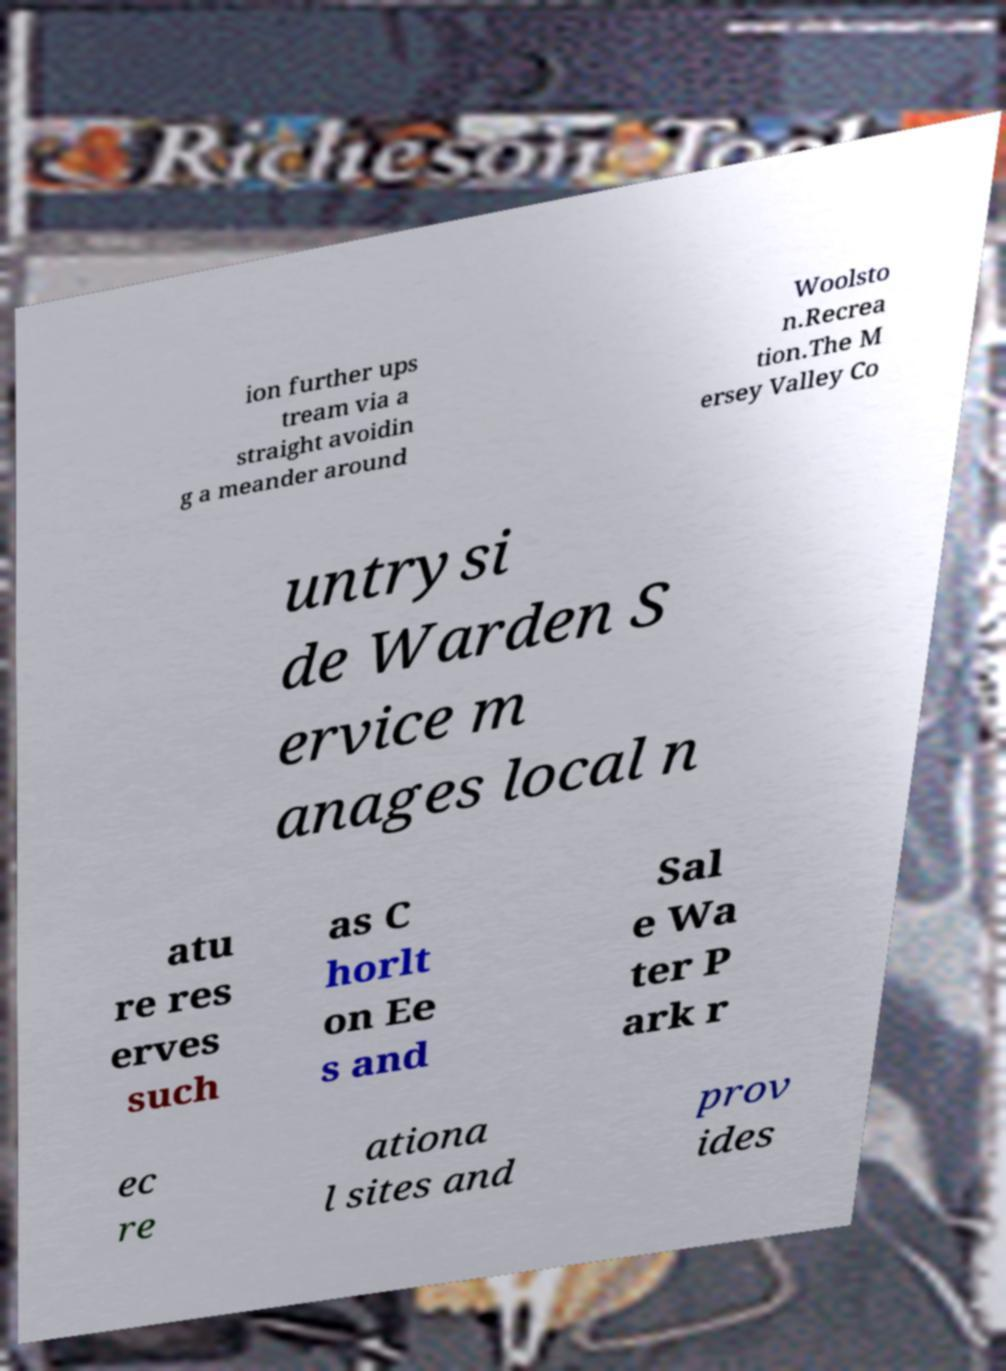For documentation purposes, I need the text within this image transcribed. Could you provide that? ion further ups tream via a straight avoidin g a meander around Woolsto n.Recrea tion.The M ersey Valley Co untrysi de Warden S ervice m anages local n atu re res erves such as C horlt on Ee s and Sal e Wa ter P ark r ec re ationa l sites and prov ides 